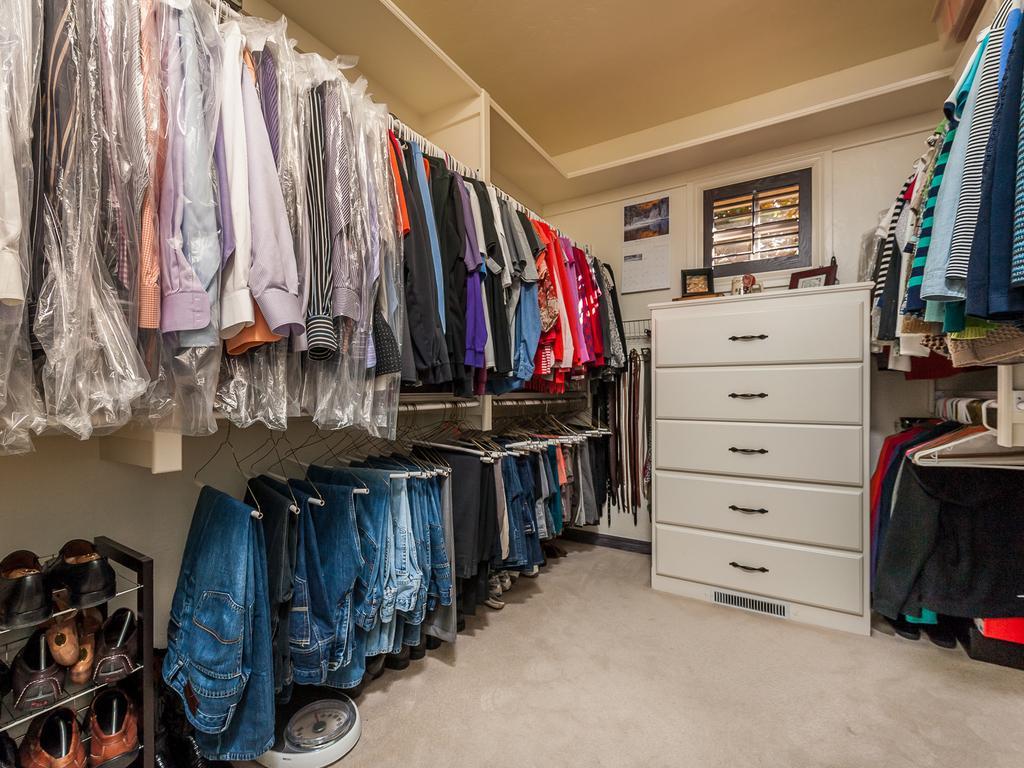Can you describe this image briefly? This picture is taken inside the room. In this image, on the right side, we can see some shirts with hanger. In the middle of the image, we can see a shelf, on the shelf, we can see some photo frames. On the left side, we can see some shirts and jeans. In the left corner, we can see a chapel stand. In the background, we can see some belts, calendar, window. At the top, we can see a roof, at the bottom, we can see a weight machine. 